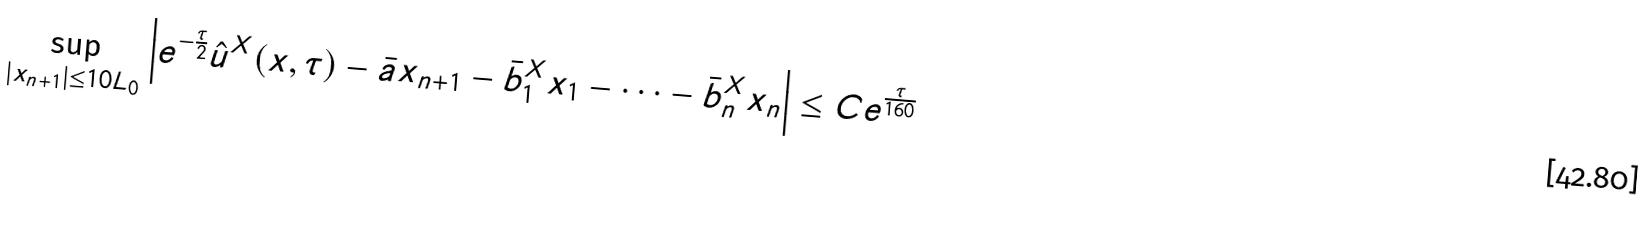<formula> <loc_0><loc_0><loc_500><loc_500>\sup _ { | x _ { n + 1 } | \leq 1 0 L _ { 0 } } \left | e ^ { - \frac { \tau } { 2 } } \hat { u } ^ { X } ( x , \tau ) - \bar { a } x _ { n + 1 } - \bar { b } _ { 1 } ^ { X } x _ { 1 } - \cdots - \bar { b } _ { n } ^ { X } x _ { n } \right | \leq C e ^ { \frac { \tau } { 1 6 0 } }</formula> 